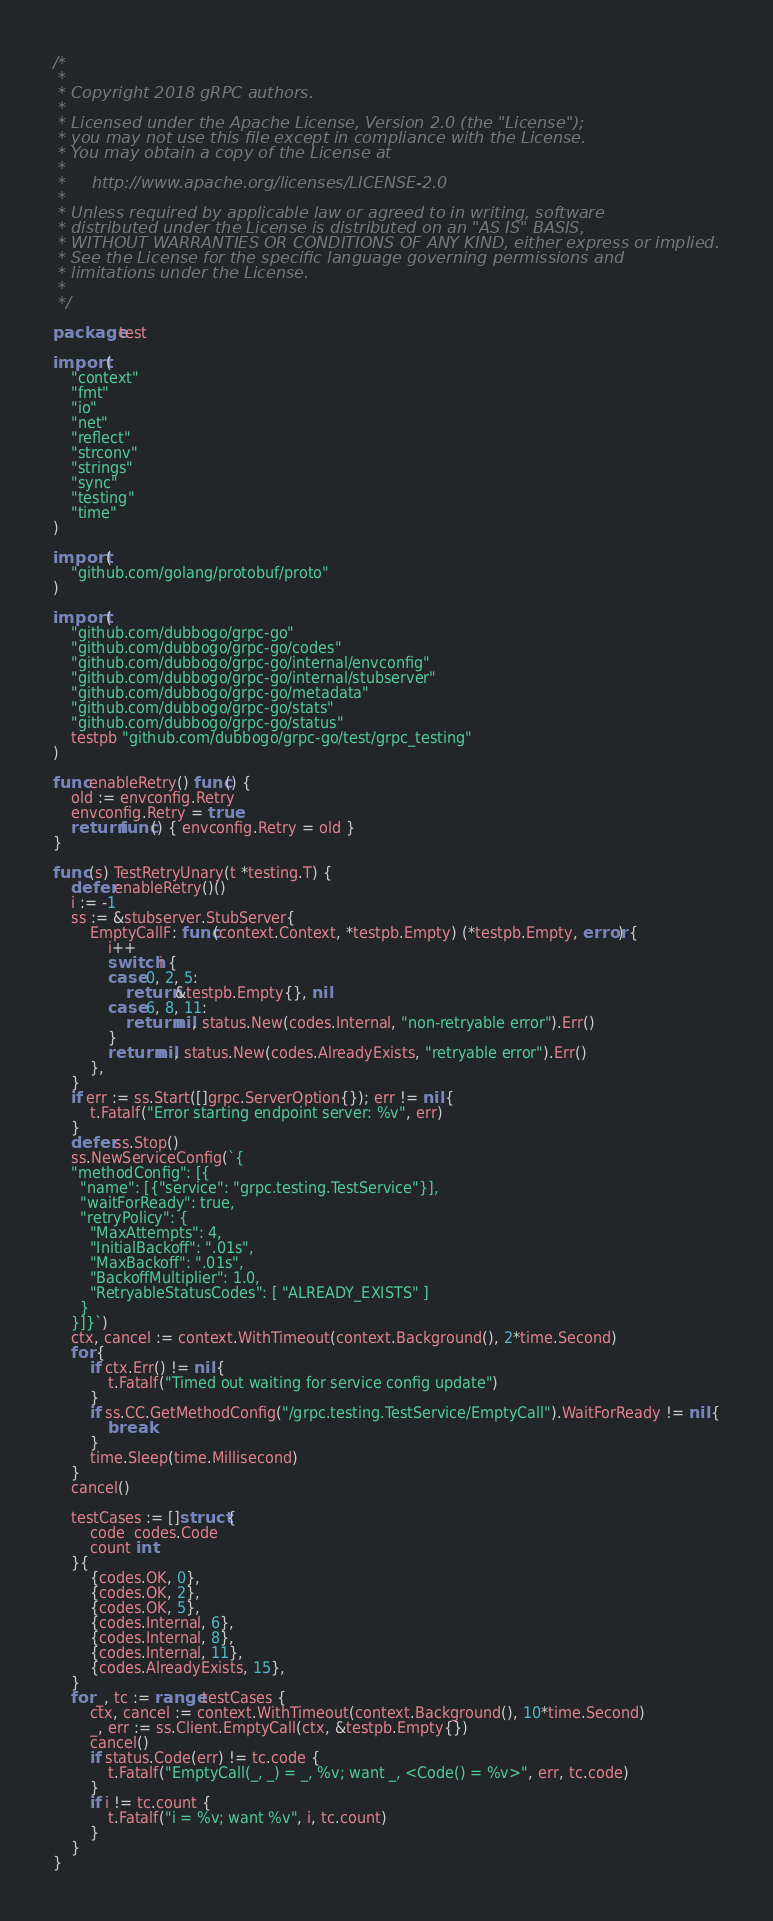Convert code to text. <code><loc_0><loc_0><loc_500><loc_500><_Go_>/*
 *
 * Copyright 2018 gRPC authors.
 *
 * Licensed under the Apache License, Version 2.0 (the "License");
 * you may not use this file except in compliance with the License.
 * You may obtain a copy of the License at
 *
 *     http://www.apache.org/licenses/LICENSE-2.0
 *
 * Unless required by applicable law or agreed to in writing, software
 * distributed under the License is distributed on an "AS IS" BASIS,
 * WITHOUT WARRANTIES OR CONDITIONS OF ANY KIND, either express or implied.
 * See the License for the specific language governing permissions and
 * limitations under the License.
 *
 */

package test

import (
	"context"
	"fmt"
	"io"
	"net"
	"reflect"
	"strconv"
	"strings"
	"sync"
	"testing"
	"time"
)

import (
	"github.com/golang/protobuf/proto"
)

import (
	"github.com/dubbogo/grpc-go"
	"github.com/dubbogo/grpc-go/codes"
	"github.com/dubbogo/grpc-go/internal/envconfig"
	"github.com/dubbogo/grpc-go/internal/stubserver"
	"github.com/dubbogo/grpc-go/metadata"
	"github.com/dubbogo/grpc-go/stats"
	"github.com/dubbogo/grpc-go/status"
	testpb "github.com/dubbogo/grpc-go/test/grpc_testing"
)

func enableRetry() func() {
	old := envconfig.Retry
	envconfig.Retry = true
	return func() { envconfig.Retry = old }
}

func (s) TestRetryUnary(t *testing.T) {
	defer enableRetry()()
	i := -1
	ss := &stubserver.StubServer{
		EmptyCallF: func(context.Context, *testpb.Empty) (*testpb.Empty, error) {
			i++
			switch i {
			case 0, 2, 5:
				return &testpb.Empty{}, nil
			case 6, 8, 11:
				return nil, status.New(codes.Internal, "non-retryable error").Err()
			}
			return nil, status.New(codes.AlreadyExists, "retryable error").Err()
		},
	}
	if err := ss.Start([]grpc.ServerOption{}); err != nil {
		t.Fatalf("Error starting endpoint server: %v", err)
	}
	defer ss.Stop()
	ss.NewServiceConfig(`{
    "methodConfig": [{
      "name": [{"service": "grpc.testing.TestService"}],
      "waitForReady": true,
      "retryPolicy": {
        "MaxAttempts": 4,
        "InitialBackoff": ".01s",
        "MaxBackoff": ".01s",
        "BackoffMultiplier": 1.0,
        "RetryableStatusCodes": [ "ALREADY_EXISTS" ]
      }
    }]}`)
	ctx, cancel := context.WithTimeout(context.Background(), 2*time.Second)
	for {
		if ctx.Err() != nil {
			t.Fatalf("Timed out waiting for service config update")
		}
		if ss.CC.GetMethodConfig("/grpc.testing.TestService/EmptyCall").WaitForReady != nil {
			break
		}
		time.Sleep(time.Millisecond)
	}
	cancel()

	testCases := []struct {
		code  codes.Code
		count int
	}{
		{codes.OK, 0},
		{codes.OK, 2},
		{codes.OK, 5},
		{codes.Internal, 6},
		{codes.Internal, 8},
		{codes.Internal, 11},
		{codes.AlreadyExists, 15},
	}
	for _, tc := range testCases {
		ctx, cancel := context.WithTimeout(context.Background(), 10*time.Second)
		_, err := ss.Client.EmptyCall(ctx, &testpb.Empty{})
		cancel()
		if status.Code(err) != tc.code {
			t.Fatalf("EmptyCall(_, _) = _, %v; want _, <Code() = %v>", err, tc.code)
		}
		if i != tc.count {
			t.Fatalf("i = %v; want %v", i, tc.count)
		}
	}
}
</code> 